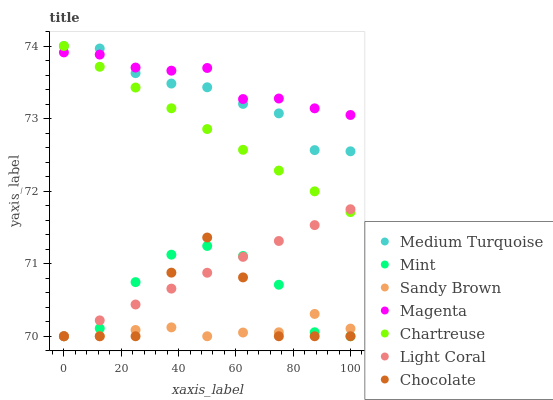Does Sandy Brown have the minimum area under the curve?
Answer yes or no. Yes. Does Magenta have the maximum area under the curve?
Answer yes or no. Yes. Does Chocolate have the minimum area under the curve?
Answer yes or no. No. Does Chocolate have the maximum area under the curve?
Answer yes or no. No. Is Chartreuse the smoothest?
Answer yes or no. Yes. Is Chocolate the roughest?
Answer yes or no. Yes. Is Light Coral the smoothest?
Answer yes or no. No. Is Light Coral the roughest?
Answer yes or no. No. Does Mint have the lowest value?
Answer yes or no. Yes. Does Chartreuse have the lowest value?
Answer yes or no. No. Does Medium Turquoise have the highest value?
Answer yes or no. Yes. Does Chocolate have the highest value?
Answer yes or no. No. Is Chocolate less than Magenta?
Answer yes or no. Yes. Is Chartreuse greater than Chocolate?
Answer yes or no. Yes. Does Light Coral intersect Mint?
Answer yes or no. Yes. Is Light Coral less than Mint?
Answer yes or no. No. Is Light Coral greater than Mint?
Answer yes or no. No. Does Chocolate intersect Magenta?
Answer yes or no. No. 